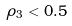<formula> <loc_0><loc_0><loc_500><loc_500>\rho _ { 3 } < 0 . 5</formula> 